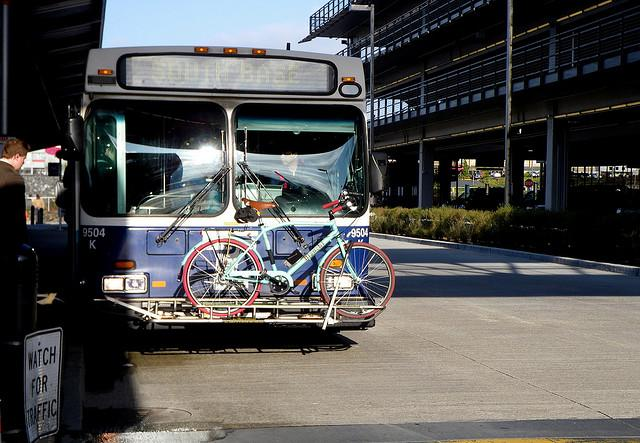Where is the rider of the bike?

Choices:
A) at home
B) in store
C) behind bus
D) in bus in bus 